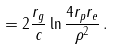<formula> <loc_0><loc_0><loc_500><loc_500>= 2 \frac { r _ { g } } { c } \ln \frac { 4 r _ { p } r _ { e } } { \rho ^ { 2 } } \, .</formula> 